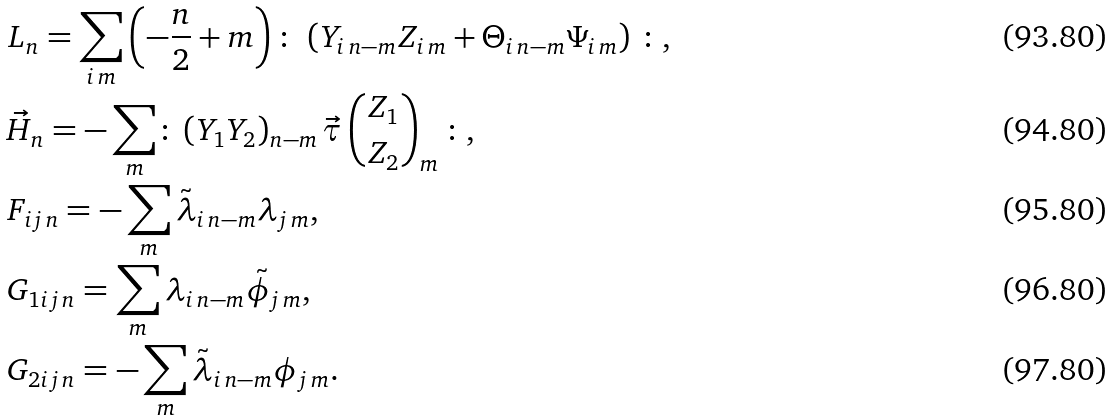Convert formula to latex. <formula><loc_0><loc_0><loc_500><loc_500>& L _ { n } = \sum _ { i \, m } \left ( - \frac { n } { 2 } + m \right ) \colon \, \left ( Y _ { i \, n - m } Z _ { i \, m } + \Theta _ { i \, n - m } \Psi _ { i \, m } \right ) \, \colon , \\ & \vec { H } _ { n } = - \sum _ { m } \colon \, ( Y _ { 1 } Y _ { 2 } ) _ { n - m } \, \vec { \tau } \, { \binom { Z _ { 1 } } { Z _ { 2 } } } _ { m } \, \colon , \\ & F _ { i j \, n } = - \sum _ { m } \tilde { \lambda } _ { i \, n - m } \lambda _ { j \, m } , \\ & G _ { 1 i j \, n } = \sum _ { m } \lambda _ { i \, n - m } \tilde { \phi } _ { j \, m } , \\ & G _ { 2 i j \, n } = - \sum _ { m } \tilde { \lambda } _ { i \, n - m } \phi _ { j \, m } .</formula> 